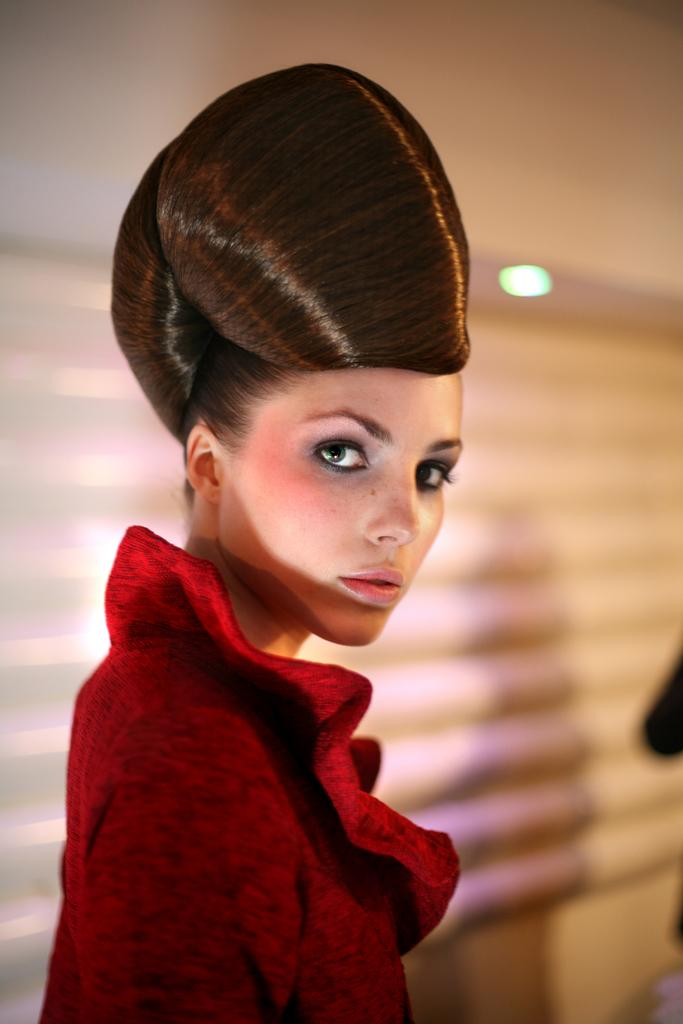Who is the main subject in the image? There is a girl in the image. What can be seen in the background of the image? There is a shadow on the wall, light, and an object in the background of the image. What is the best route to take to reach the pin in the image? There is no pin present in the image, so it is not possible to determine the best route to reach it. 